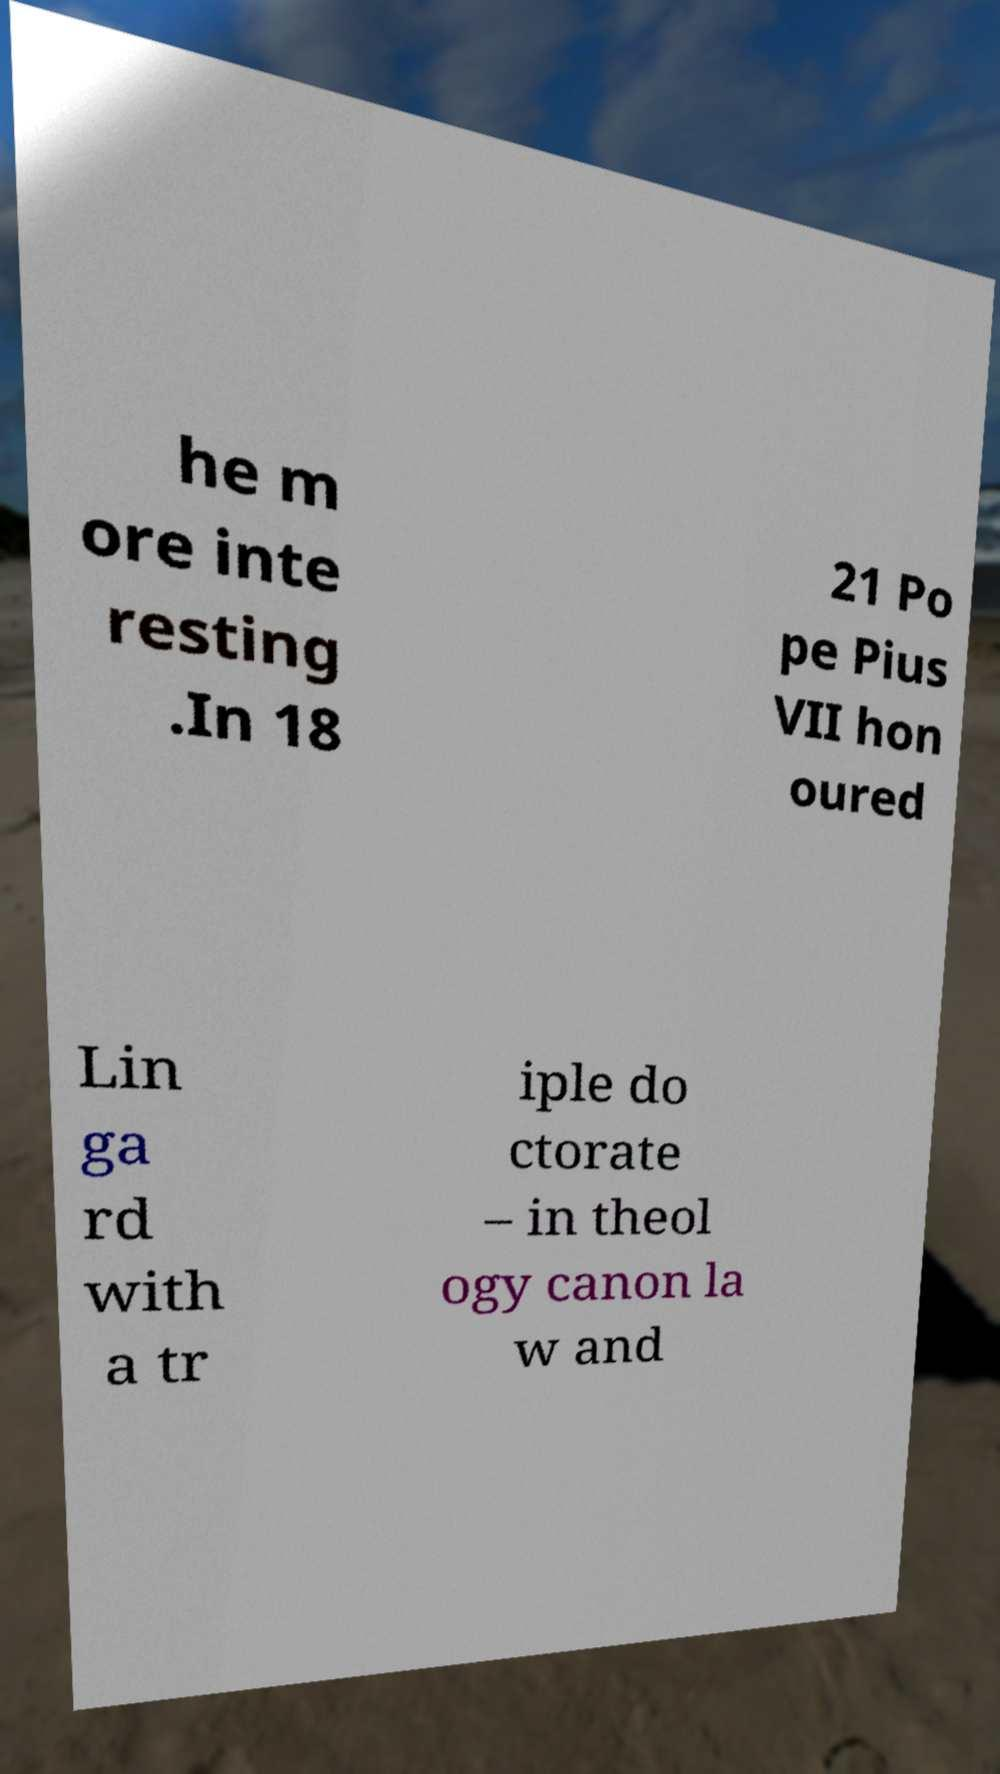Could you extract and type out the text from this image? he m ore inte resting .In 18 21 Po pe Pius VII hon oured Lin ga rd with a tr iple do ctorate – in theol ogy canon la w and 